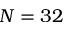Convert formula to latex. <formula><loc_0><loc_0><loc_500><loc_500>N = 3 2</formula> 